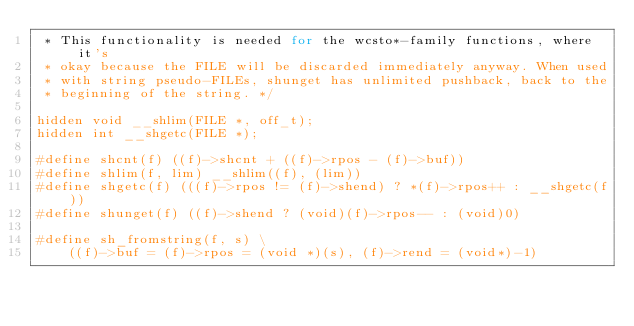<code> <loc_0><loc_0><loc_500><loc_500><_C_> * This functionality is needed for the wcsto*-family functions, where it's
 * okay because the FILE will be discarded immediately anyway. When used
 * with string pseudo-FILEs, shunget has unlimited pushback, back to the
 * beginning of the string. */

hidden void __shlim(FILE *, off_t);
hidden int __shgetc(FILE *);

#define shcnt(f) ((f)->shcnt + ((f)->rpos - (f)->buf))
#define shlim(f, lim) __shlim((f), (lim))
#define shgetc(f) (((f)->rpos != (f)->shend) ? *(f)->rpos++ : __shgetc(f))
#define shunget(f) ((f)->shend ? (void)(f)->rpos-- : (void)0)

#define sh_fromstring(f, s) \
	((f)->buf = (f)->rpos = (void *)(s), (f)->rend = (void*)-1)
</code> 